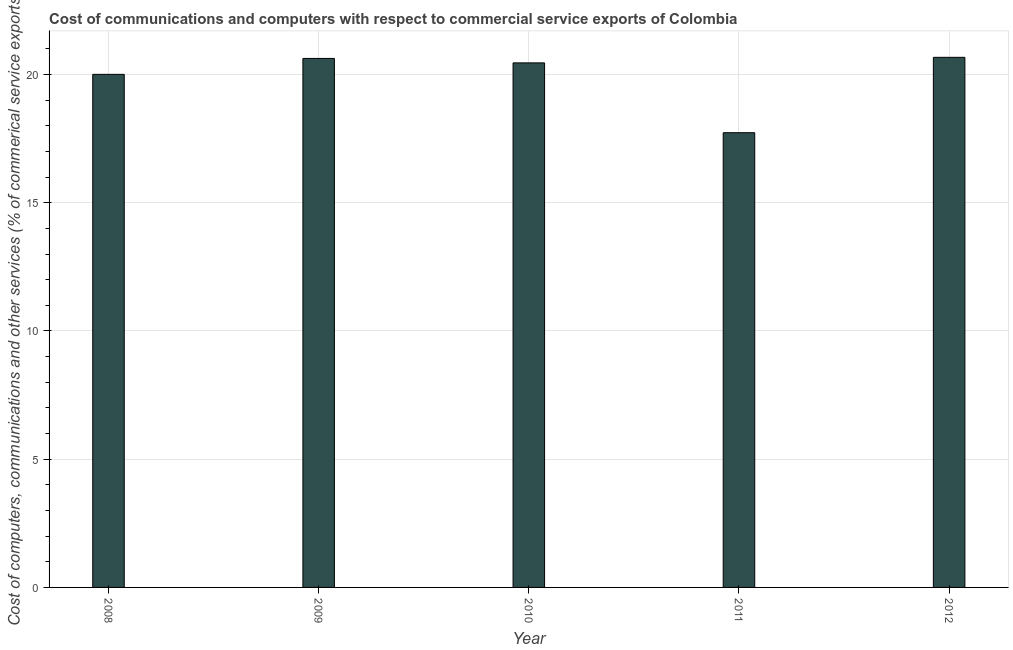Does the graph contain grids?
Provide a short and direct response. Yes. What is the title of the graph?
Offer a terse response. Cost of communications and computers with respect to commercial service exports of Colombia. What is the label or title of the Y-axis?
Your response must be concise. Cost of computers, communications and other services (% of commerical service exports). What is the  computer and other services in 2012?
Keep it short and to the point. 20.67. Across all years, what is the maximum cost of communications?
Offer a very short reply. 20.67. Across all years, what is the minimum cost of communications?
Offer a terse response. 17.73. In which year was the  computer and other services maximum?
Ensure brevity in your answer.  2012. In which year was the  computer and other services minimum?
Keep it short and to the point. 2011. What is the sum of the cost of communications?
Provide a succinct answer. 99.48. What is the difference between the  computer and other services in 2008 and 2009?
Your response must be concise. -0.62. What is the average cost of communications per year?
Give a very brief answer. 19.9. What is the median cost of communications?
Make the answer very short. 20.45. In how many years, is the cost of communications greater than 15 %?
Keep it short and to the point. 5. What is the ratio of the  computer and other services in 2008 to that in 2012?
Give a very brief answer. 0.97. Is the difference between the cost of communications in 2010 and 2011 greater than the difference between any two years?
Your response must be concise. No. What is the difference between the highest and the second highest  computer and other services?
Your answer should be compact. 0.04. Is the sum of the cost of communications in 2008 and 2009 greater than the maximum cost of communications across all years?
Your answer should be very brief. Yes. What is the difference between the highest and the lowest  computer and other services?
Provide a succinct answer. 2.94. Are all the bars in the graph horizontal?
Offer a very short reply. No. How many years are there in the graph?
Offer a very short reply. 5. What is the difference between two consecutive major ticks on the Y-axis?
Provide a succinct answer. 5. What is the Cost of computers, communications and other services (% of commerical service exports) of 2008?
Ensure brevity in your answer.  20. What is the Cost of computers, communications and other services (% of commerical service exports) of 2009?
Your answer should be very brief. 20.63. What is the Cost of computers, communications and other services (% of commerical service exports) of 2010?
Keep it short and to the point. 20.45. What is the Cost of computers, communications and other services (% of commerical service exports) of 2011?
Your response must be concise. 17.73. What is the Cost of computers, communications and other services (% of commerical service exports) in 2012?
Keep it short and to the point. 20.67. What is the difference between the Cost of computers, communications and other services (% of commerical service exports) in 2008 and 2009?
Your answer should be compact. -0.62. What is the difference between the Cost of computers, communications and other services (% of commerical service exports) in 2008 and 2010?
Provide a short and direct response. -0.45. What is the difference between the Cost of computers, communications and other services (% of commerical service exports) in 2008 and 2011?
Your answer should be compact. 2.28. What is the difference between the Cost of computers, communications and other services (% of commerical service exports) in 2008 and 2012?
Your answer should be very brief. -0.66. What is the difference between the Cost of computers, communications and other services (% of commerical service exports) in 2009 and 2010?
Keep it short and to the point. 0.17. What is the difference between the Cost of computers, communications and other services (% of commerical service exports) in 2009 and 2011?
Your response must be concise. 2.9. What is the difference between the Cost of computers, communications and other services (% of commerical service exports) in 2009 and 2012?
Make the answer very short. -0.04. What is the difference between the Cost of computers, communications and other services (% of commerical service exports) in 2010 and 2011?
Provide a short and direct response. 2.72. What is the difference between the Cost of computers, communications and other services (% of commerical service exports) in 2010 and 2012?
Keep it short and to the point. -0.22. What is the difference between the Cost of computers, communications and other services (% of commerical service exports) in 2011 and 2012?
Offer a terse response. -2.94. What is the ratio of the Cost of computers, communications and other services (% of commerical service exports) in 2008 to that in 2011?
Give a very brief answer. 1.13. What is the ratio of the Cost of computers, communications and other services (% of commerical service exports) in 2009 to that in 2011?
Keep it short and to the point. 1.16. What is the ratio of the Cost of computers, communications and other services (% of commerical service exports) in 2009 to that in 2012?
Keep it short and to the point. 1. What is the ratio of the Cost of computers, communications and other services (% of commerical service exports) in 2010 to that in 2011?
Provide a short and direct response. 1.15. What is the ratio of the Cost of computers, communications and other services (% of commerical service exports) in 2011 to that in 2012?
Your response must be concise. 0.86. 